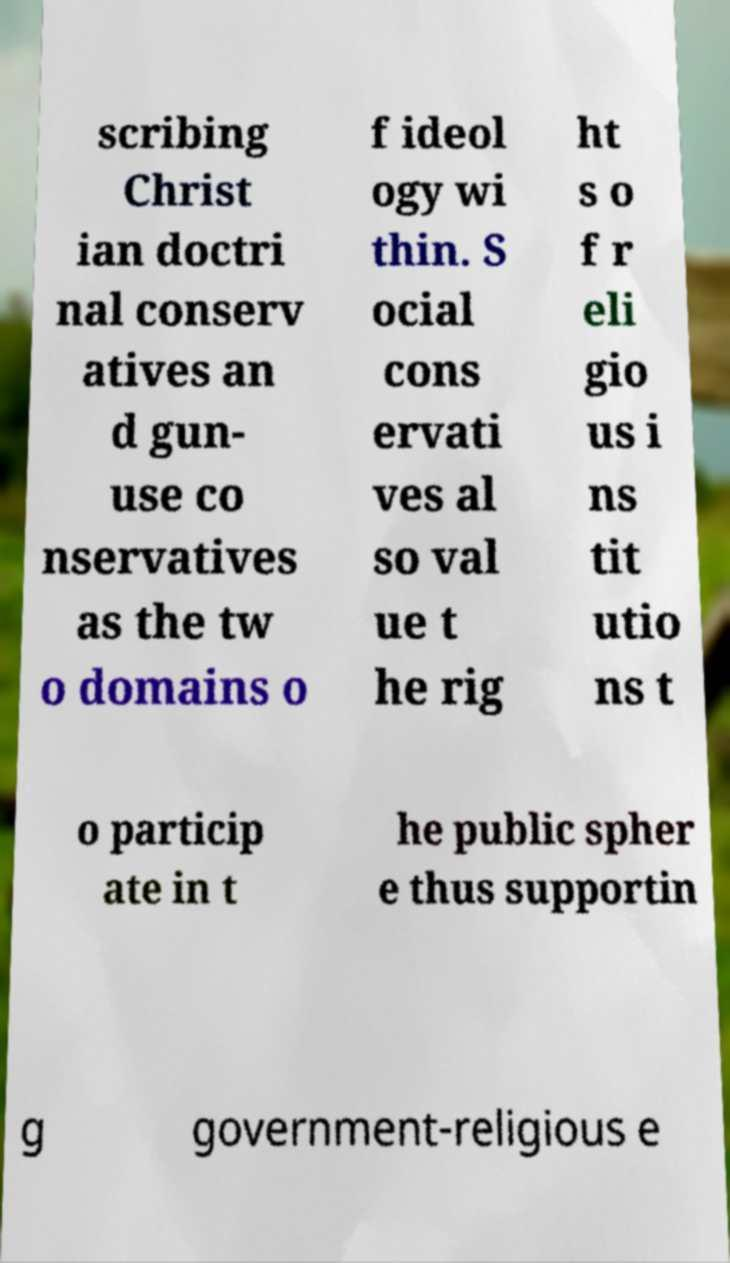Could you assist in decoding the text presented in this image and type it out clearly? scribing Christ ian doctri nal conserv atives an d gun- use co nservatives as the tw o domains o f ideol ogy wi thin. S ocial cons ervati ves al so val ue t he rig ht s o f r eli gio us i ns tit utio ns t o particip ate in t he public spher e thus supportin g government-religious e 